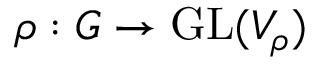<formula> <loc_0><loc_0><loc_500><loc_500>\rho \colon G \to { G L } ( V _ { \rho } )</formula> 